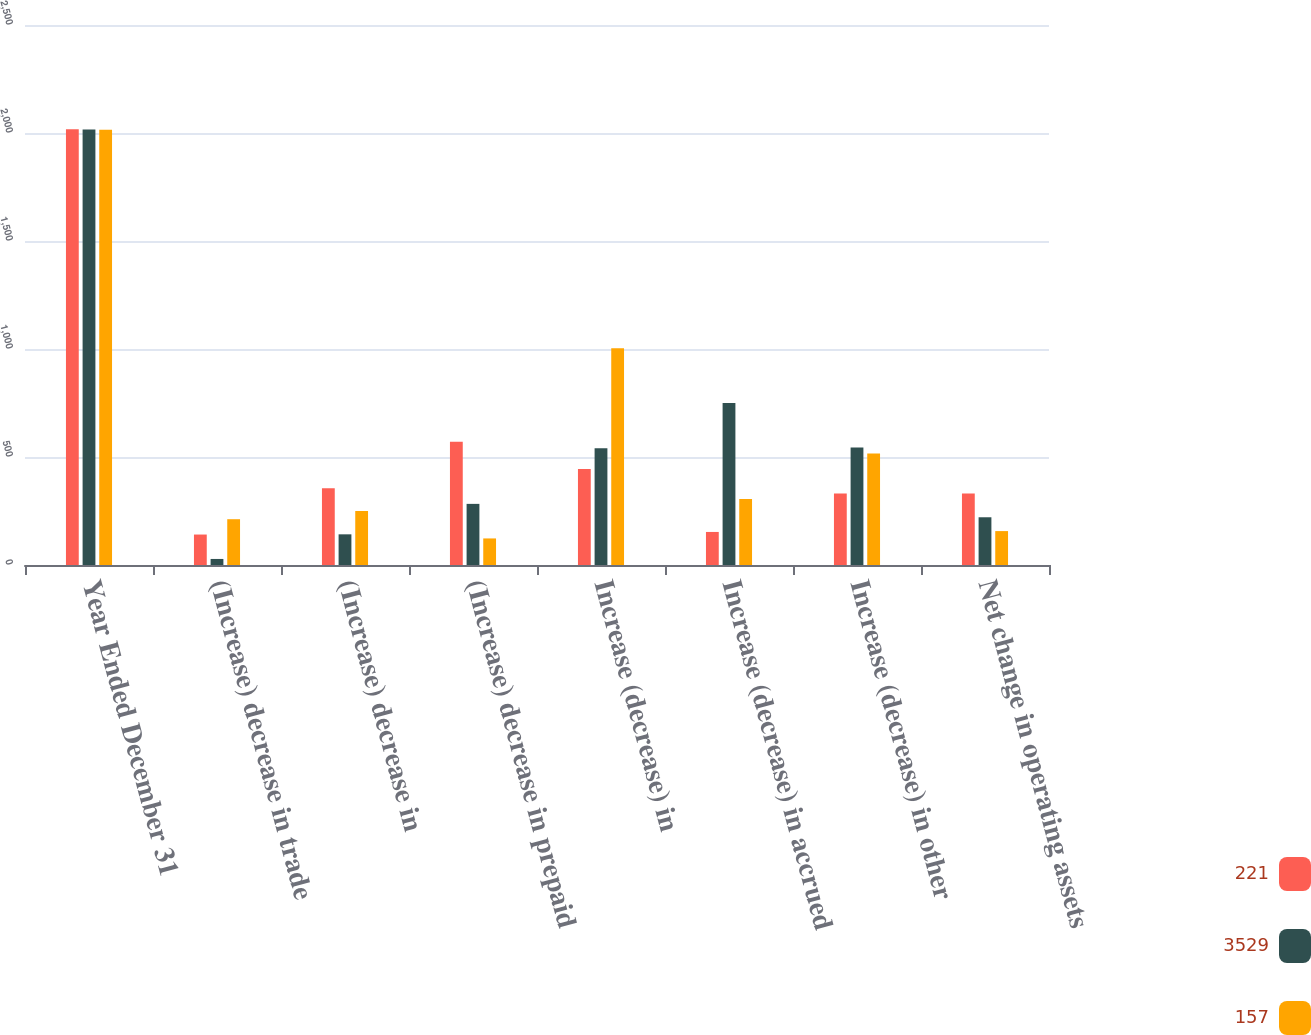<chart> <loc_0><loc_0><loc_500><loc_500><stacked_bar_chart><ecel><fcel>Year Ended December 31<fcel>(Increase) decrease in trade<fcel>(Increase) decrease in<fcel>(Increase) decrease in prepaid<fcel>Increase (decrease) in<fcel>Increase (decrease) in accrued<fcel>Increase (decrease) in other<fcel>Net change in operating assets<nl><fcel>221<fcel>2017<fcel>141<fcel>355<fcel>571<fcel>445<fcel>153<fcel>330.5<fcel>330.5<nl><fcel>3529<fcel>2016<fcel>28<fcel>142<fcel>283<fcel>540<fcel>750<fcel>544<fcel>221<nl><fcel>157<fcel>2015<fcel>212<fcel>250<fcel>123<fcel>1004<fcel>306<fcel>516<fcel>157<nl></chart> 